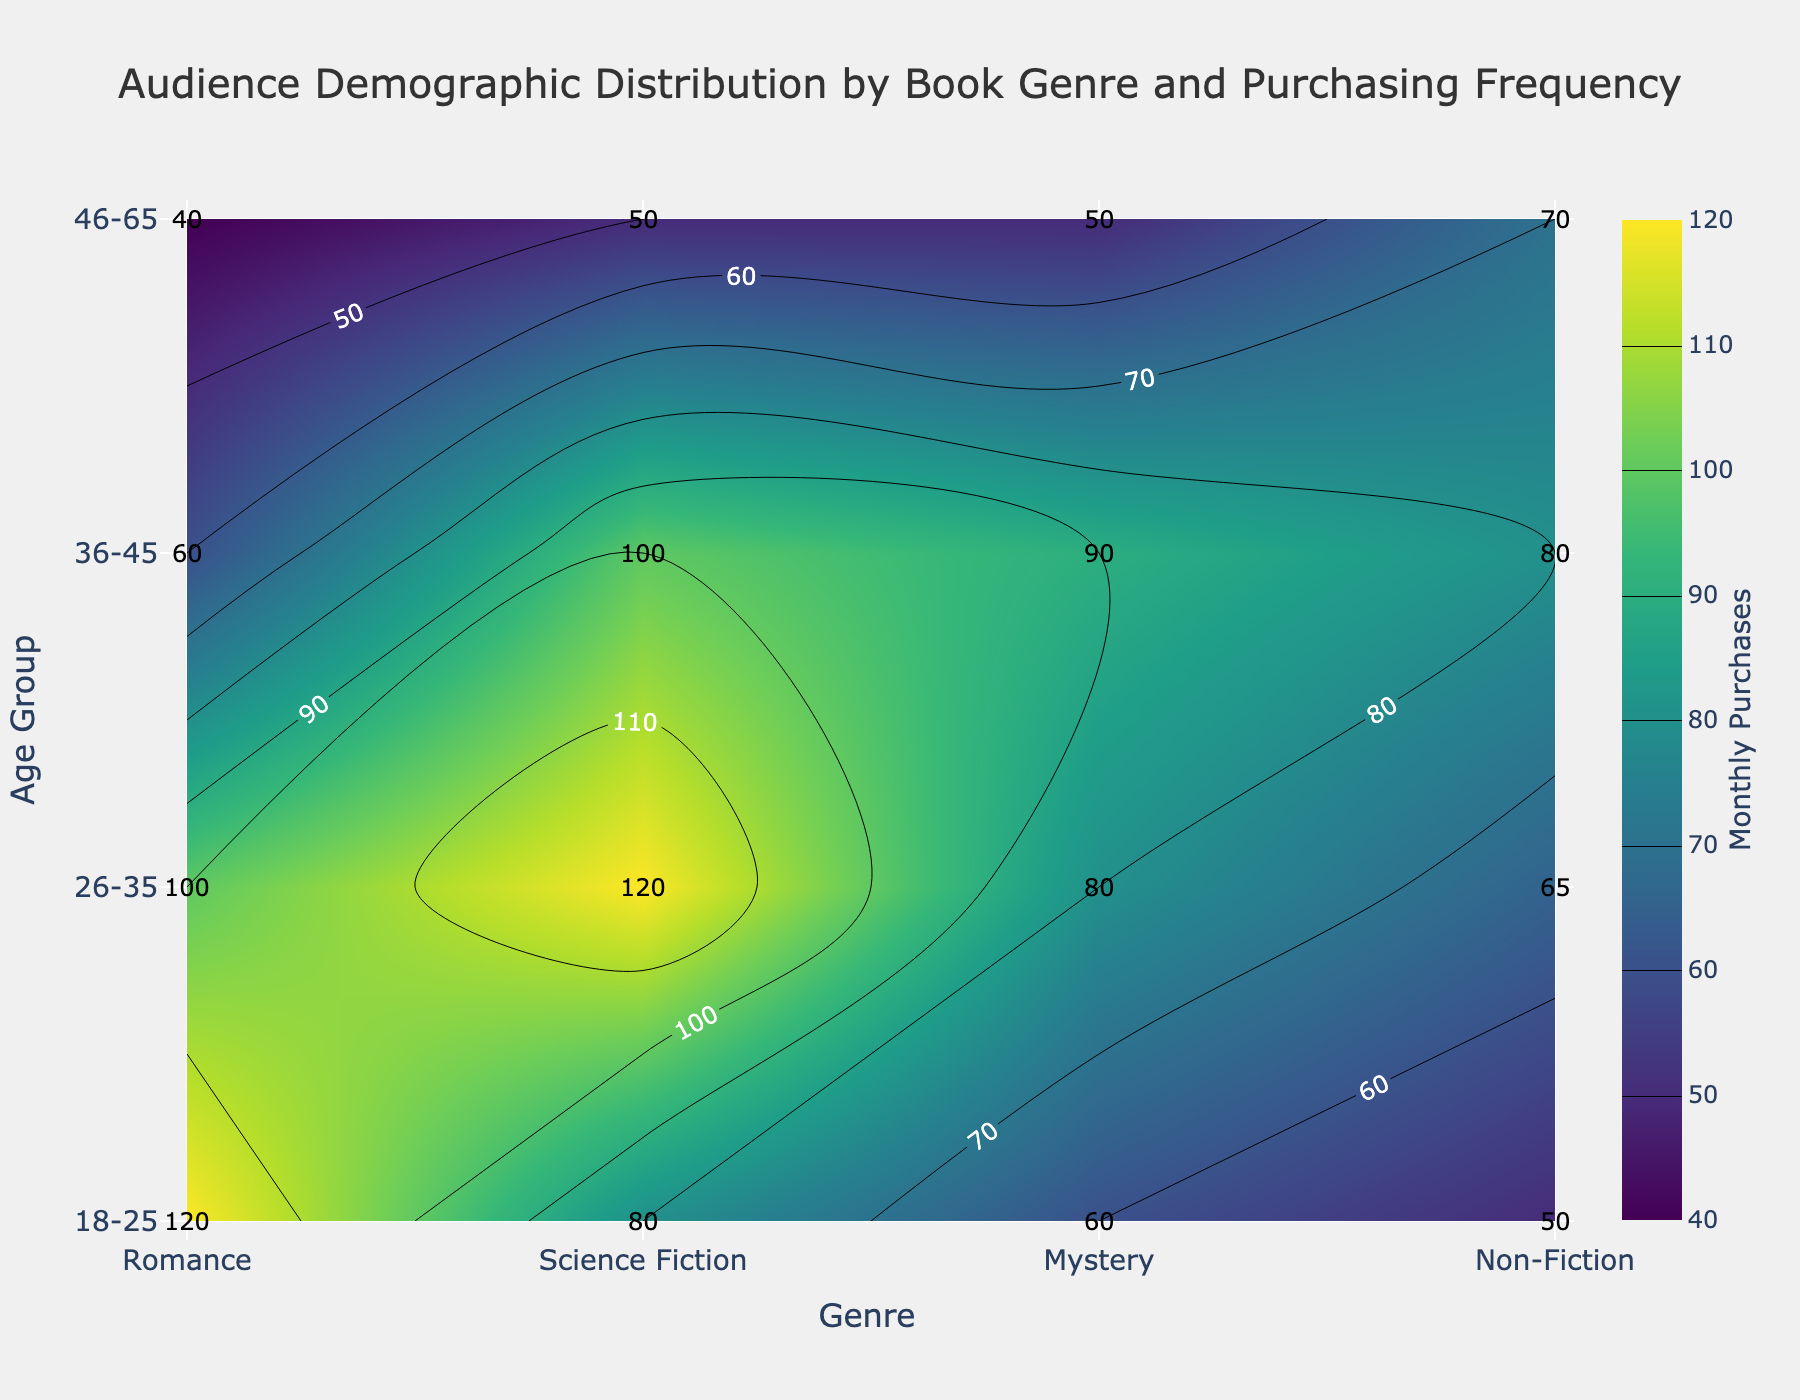what is the title of the figure? The title is usually displayed at the top of the figure. In this case, it says "Audience Demographic Distribution by Book Genre and Purchasing Frequency".
Answer: Audience Demographic Distribution by Book Genre and Purchasing Frequency What are the x-axis and y-axis labels? Axis labels are typically found along the respective axes. Here, the x-axis is labeled "Genre" and the y-axis is labeled "Age Group".
Answer: Genre; Age Group Which age group has the highest purchasing frequency for Romance books? Look at the contour plot for the Romance genre and check the numbers representing purchasing frequencies. The highest frequency value is in the age group 18-25, which is 120.
Answer: 18-25 How many monthly purchases do 26-35 year-olds make in the Science Fiction genre? Find the value on the contour plot at the intersection of the age group 26-35 and the Science Fiction genre. This value is labeled as 120.
Answer: 120 Compare the monthly purchases of the 18-25 age group in the Romance genre with the 36-45 age group in the Science Fiction genre. Locate the values on the contour plot for the respective age groups and genres. The number for Romance 18-25 is 120, and for Science Fiction 36-45 is 100.
Answer: Romance 18-25: 120; Science Fiction 36-45: 100 What is the difference between the highest and lowest monthly purchases across all genres and age groups? Scan the contour plot and identify the highest value (120 for Romance 18-25) and the lowest value (40 for Romance 46-65). Subtract the lowest from the highest (120 - 40).
Answer: 80 Which genre has the lowest average monthly purchases for the age group 46-65? Check the values in the contour plot for the 46-65 age group across all genres. Calculate the average for each genre: Romance (40), Science Fiction (50), Mystery (50), Non-Fiction (70). The lowest average is for Romance.
Answer: Romance Are monthly purchases higher in the 26-35 age group for Science Fiction or Mystery genres? Examine the values on the contour plot for the 26-35 age group in the Science Fiction (120) and Mystery (80) genres. Compare the two values.
Answer: Science Fiction For which age group and genre combination is the monthly purchase exactly 80? Look on the contour plot for the value 80. The combinations are Science Fiction 18-25, Mystery 26-35, and Non-Fiction 36-45.
Answer: Science Fiction 18-25; Mystery 26-35; Non-Fiction 36-45 How do monthly purchases in the 18-25 age group across all genres compare visually? Observe the contour plot values for the 18-25 age group across genres: Romance (120), Science Fiction (80), Mystery (60), Non-Fiction (50).
Answer: Romance > Science Fiction > Mystery > Non-Fiction 